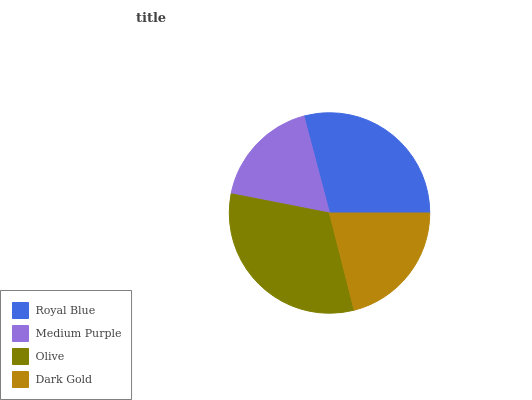Is Medium Purple the minimum?
Answer yes or no. Yes. Is Olive the maximum?
Answer yes or no. Yes. Is Olive the minimum?
Answer yes or no. No. Is Medium Purple the maximum?
Answer yes or no. No. Is Olive greater than Medium Purple?
Answer yes or no. Yes. Is Medium Purple less than Olive?
Answer yes or no. Yes. Is Medium Purple greater than Olive?
Answer yes or no. No. Is Olive less than Medium Purple?
Answer yes or no. No. Is Royal Blue the high median?
Answer yes or no. Yes. Is Dark Gold the low median?
Answer yes or no. Yes. Is Olive the high median?
Answer yes or no. No. Is Olive the low median?
Answer yes or no. No. 